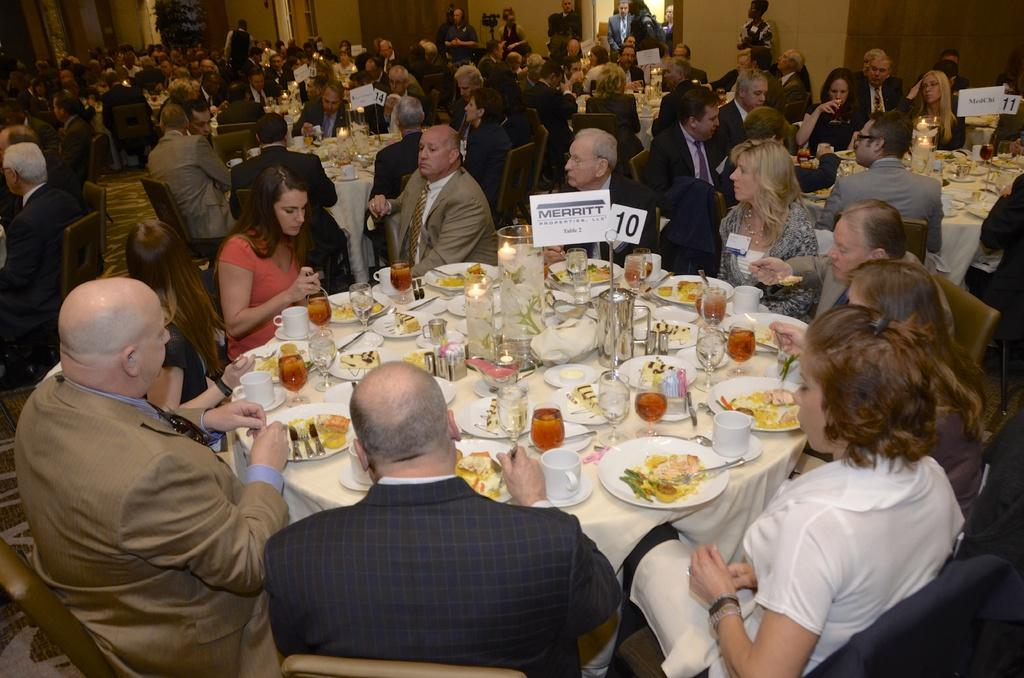What are the people in the image doing? There is a group of people sitting in chairs in the image. What is on the table in the image? There is a table in the image with plates, food, spoons, cups, saucers, a jug, glasses, a name paper, and a number board. What might the people be using to eat the food on the table? Spoons are present on the table, which they might be using to eat the food. What type of health issues are the people in the image discussing? There is no indication in the image that the people are discussing health issues. Can you see any stars in the image? There are no stars visible in the image. Is there a bomb present in the image? There is no bomb present in the image. 